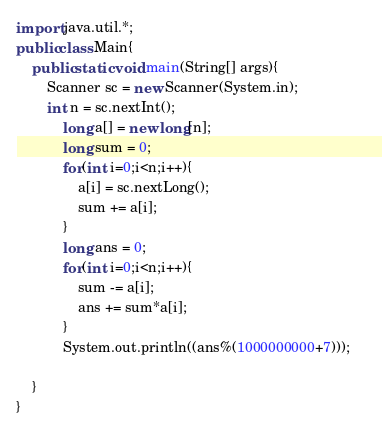<code> <loc_0><loc_0><loc_500><loc_500><_Java_>import java.util.*;
public class Main{
	public static void main(String[] args){
		Scanner sc = new Scanner(System.in);
		int n = sc.nextInt();
		    long a[] = new long[n];
		    long sum = 0;
		    for(int i=0;i<n;i++){
		        a[i] = sc.nextLong();
		        sum += a[i];
		    }
		    long ans = 0;
		    for(int i=0;i<n;i++){
		        sum -= a[i];
		        ans += sum*a[i];
		    }
		    System.out.println((ans%(1000000000+7)));    
		    
	}
}
</code> 